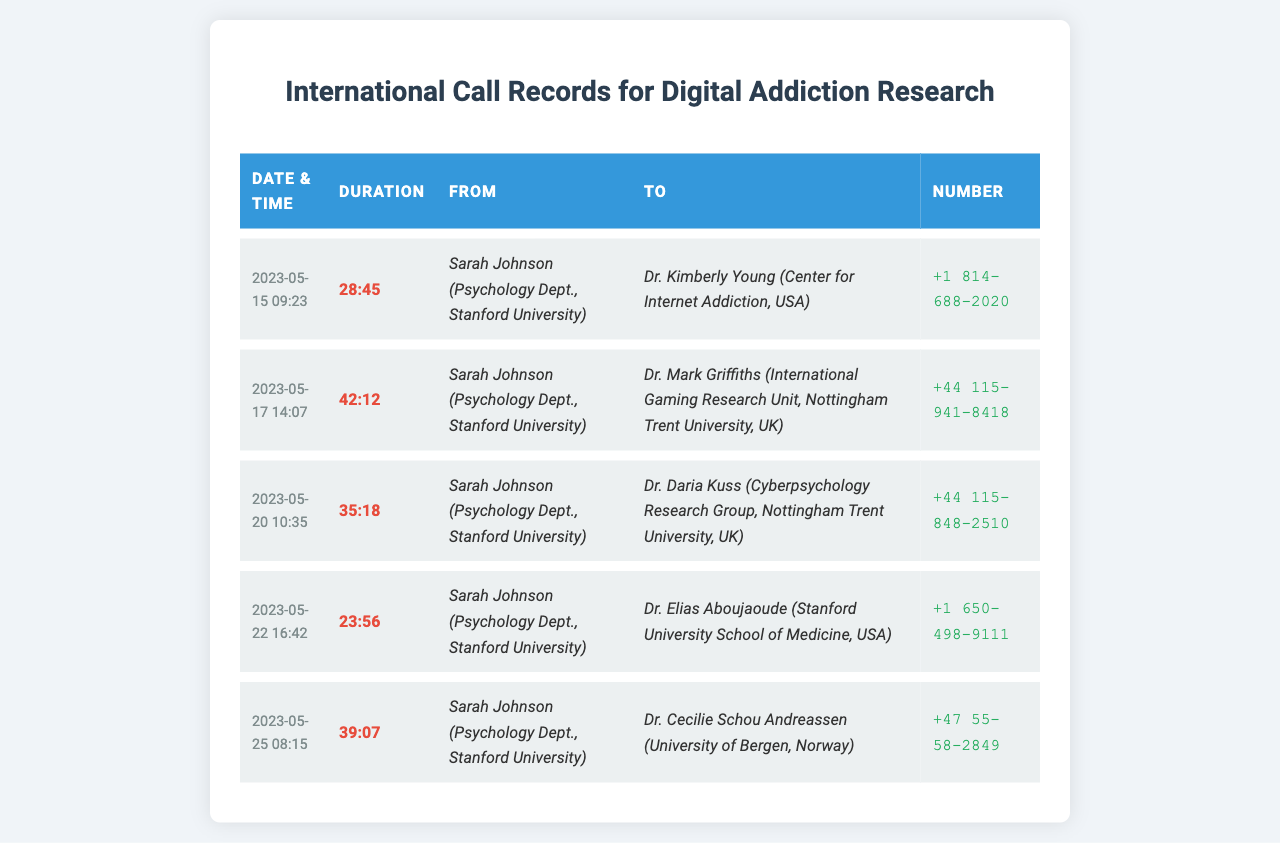what is the first call date recorded? The first call recorded in the document occurs on May 15, 2023.
Answer: May 15, 2023 who made the last call? The last call recorded is made by Sarah Johnson from the Psychology Dept., Stanford University.
Answer: Sarah Johnson what is the longest call duration? The duration of the longest call in the records is 42 minutes and 12 seconds.
Answer: 42:12 which researcher has a connection to the University of Bergen? The researcher connected to the University of Bergen in the document is Dr. Cecilie Schou Andreassen.
Answer: Dr. Cecilie Schou Andreassen how many calls were made to researchers based in the USA? There are two calls made to researchers based in the USA.
Answer: 2 what is the total duration of calls made on May 20? The call made on May 20 has a duration of 35 minutes and 18 seconds.
Answer: 35:18 which call had the shortest duration? The call with the shortest duration is 23 minutes and 56 seconds.
Answer: 23:56 how many researchers are located in the UK? There are two researchers located in the UK based on the calls listed.
Answer: 2 which university is associated with Dr. Kimberly Young? Dr. Kimberly Young is associated with the Center for Internet Addiction in the USA.
Answer: Center for Internet Addiction 